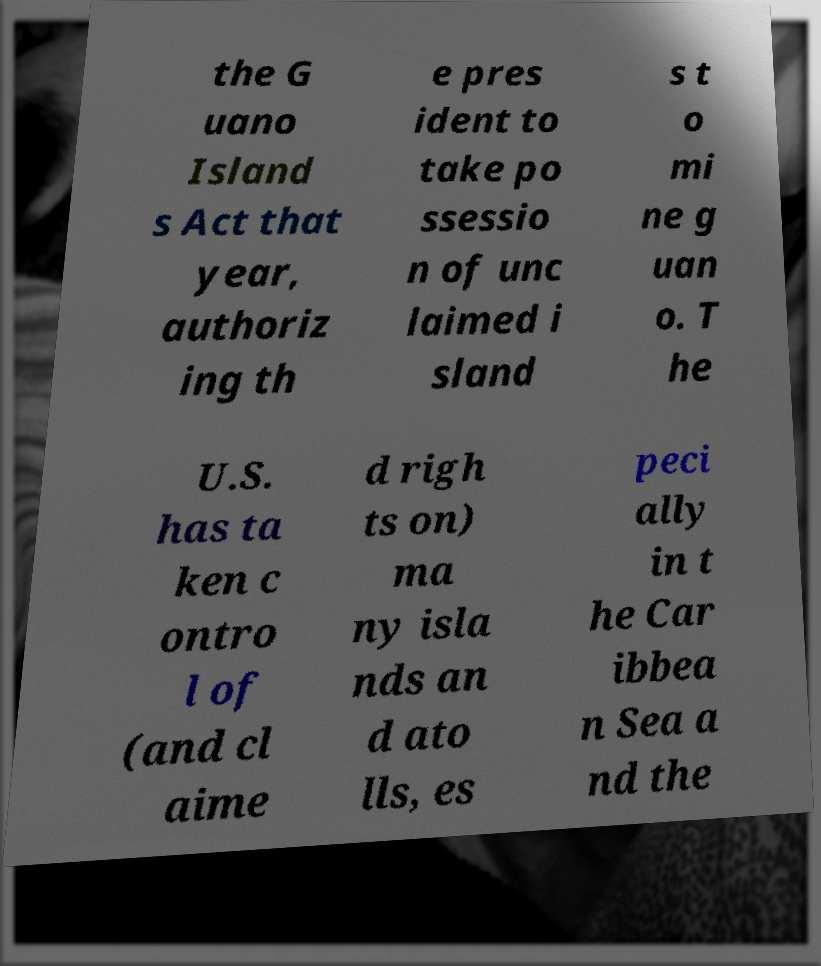Please read and relay the text visible in this image. What does it say? the G uano Island s Act that year, authoriz ing th e pres ident to take po ssessio n of unc laimed i sland s t o mi ne g uan o. T he U.S. has ta ken c ontro l of (and cl aime d righ ts on) ma ny isla nds an d ato lls, es peci ally in t he Car ibbea n Sea a nd the 